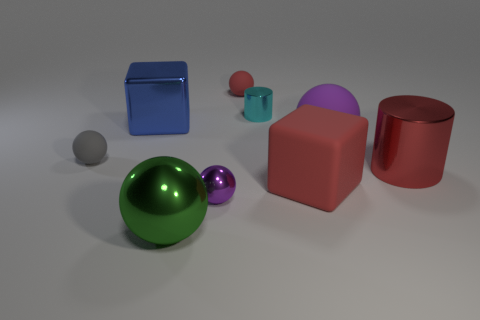What is the color of the other sphere that is the same size as the green ball?
Ensure brevity in your answer.  Purple. Is the color of the tiny metallic sphere the same as the metal cylinder behind the gray rubber object?
Give a very brief answer. No. What is the color of the tiny shiny sphere?
Keep it short and to the point. Purple. There is a cylinder to the left of the red matte block; what is it made of?
Make the answer very short. Metal. There is a red matte object that is the same shape as the tiny gray rubber thing; what is its size?
Provide a succinct answer. Small. Are there fewer cyan cylinders that are in front of the matte block than small red objects?
Provide a succinct answer. Yes. Is there a big purple matte thing?
Keep it short and to the point. Yes. What color is the other object that is the same shape as the tiny cyan object?
Your answer should be compact. Red. There is a small object that is in front of the red cube; is its color the same as the large cylinder?
Make the answer very short. No. Is the size of the gray matte sphere the same as the cyan metal thing?
Provide a short and direct response. Yes. 